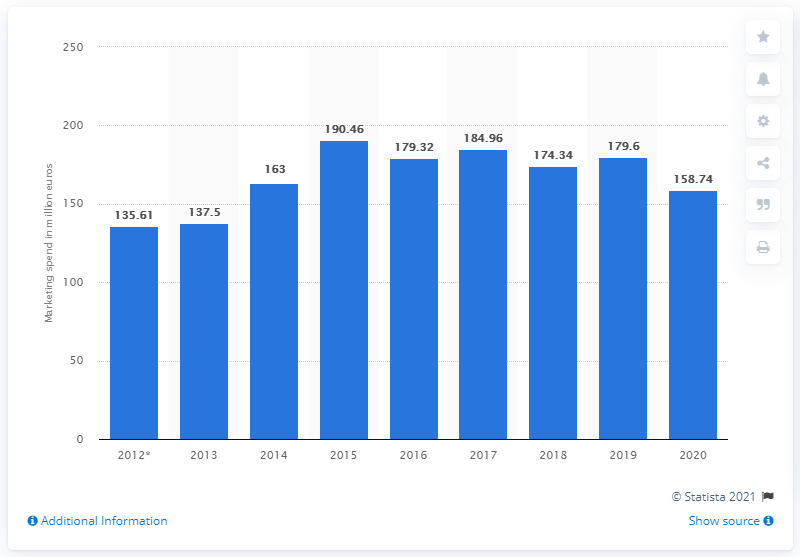Point out several critical features in this image. In 2020, Hugo Boss' global marketing expenditure was 158.74 million. 